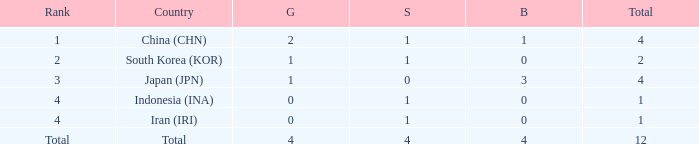What is the fewest gold medals for the nation with 4 silvers and more than 4 bronze? None. 